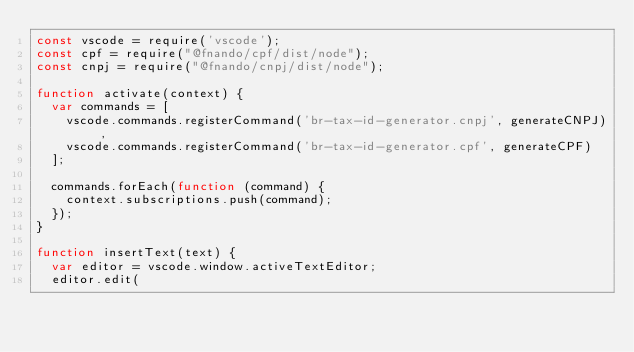Convert code to text. <code><loc_0><loc_0><loc_500><loc_500><_JavaScript_>const vscode = require('vscode');
const cpf = require("@fnando/cpf/dist/node");
const cnpj = require("@fnando/cnpj/dist/node");

function activate(context) {
  var commands = [
    vscode.commands.registerCommand('br-tax-id-generator.cnpj', generateCNPJ),
    vscode.commands.registerCommand('br-tax-id-generator.cpf', generateCPF)
  ];

  commands.forEach(function (command) {
    context.subscriptions.push(command);
  });
}

function insertText(text) {
  var editor = vscode.window.activeTextEditor;
  editor.edit(</code> 